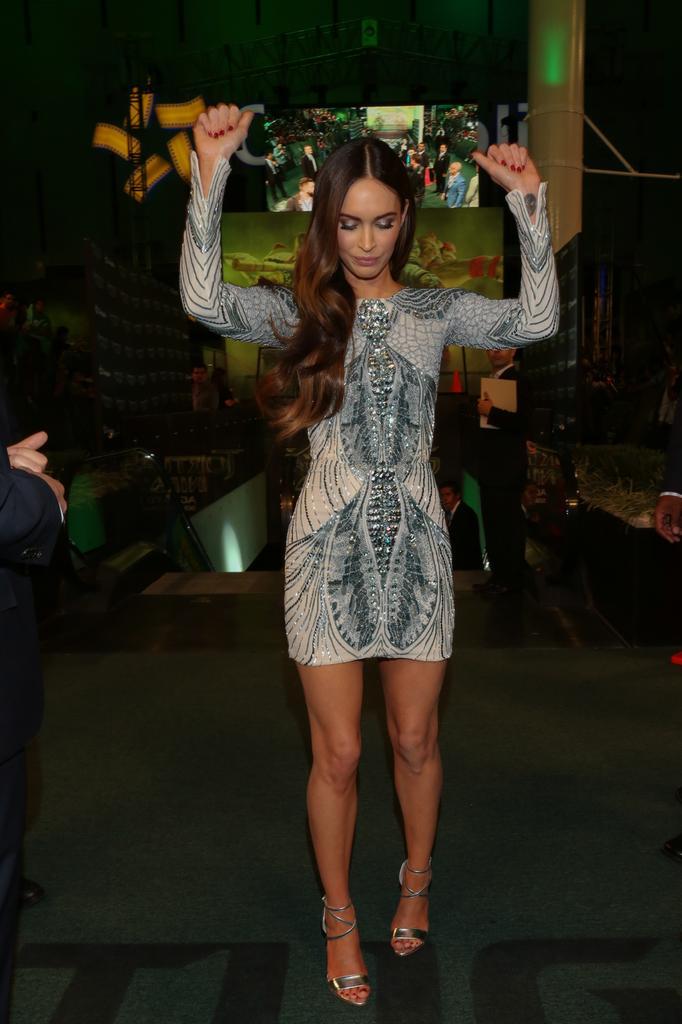Describe this image in one or two sentences. In this image there is one woman standing in middle of this image and there is a television at top of this image and there is a wall in the background. There are some objects kept at left side of this image and right side of this image. there is one person at right side of this image. 